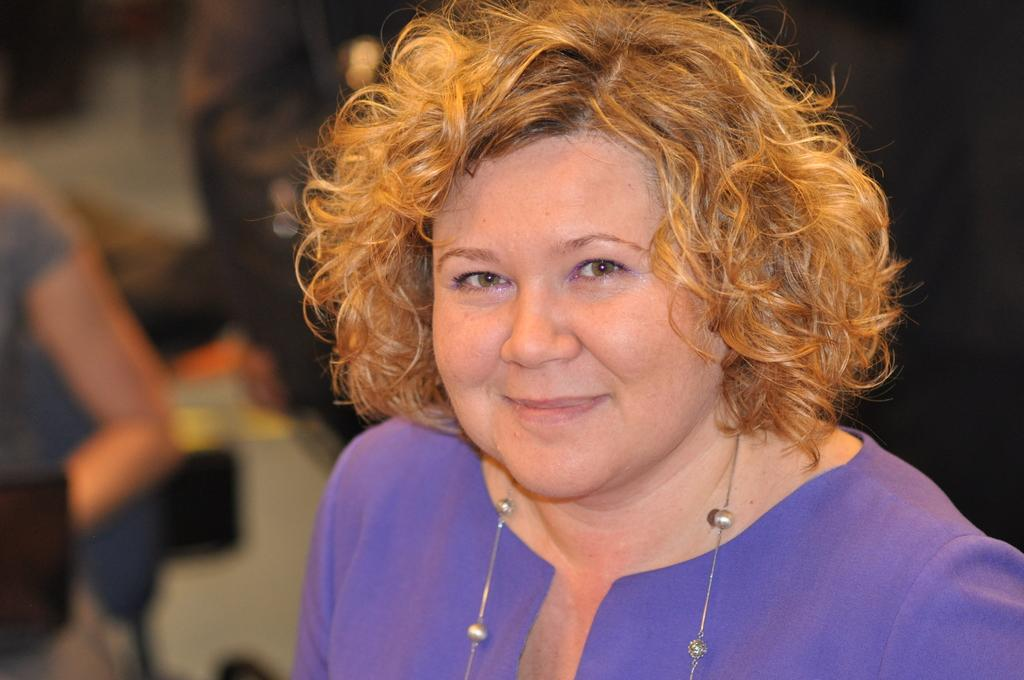Who is the main subject in the image? There is a woman in the image. What is the woman wearing? The woman is wearing a purple dress and a chain. What is the woman's facial expression in the image? The woman is smiling. What type of bone can be seen in the woman's hand in the image? There is no bone visible in the woman's hand in the image. 